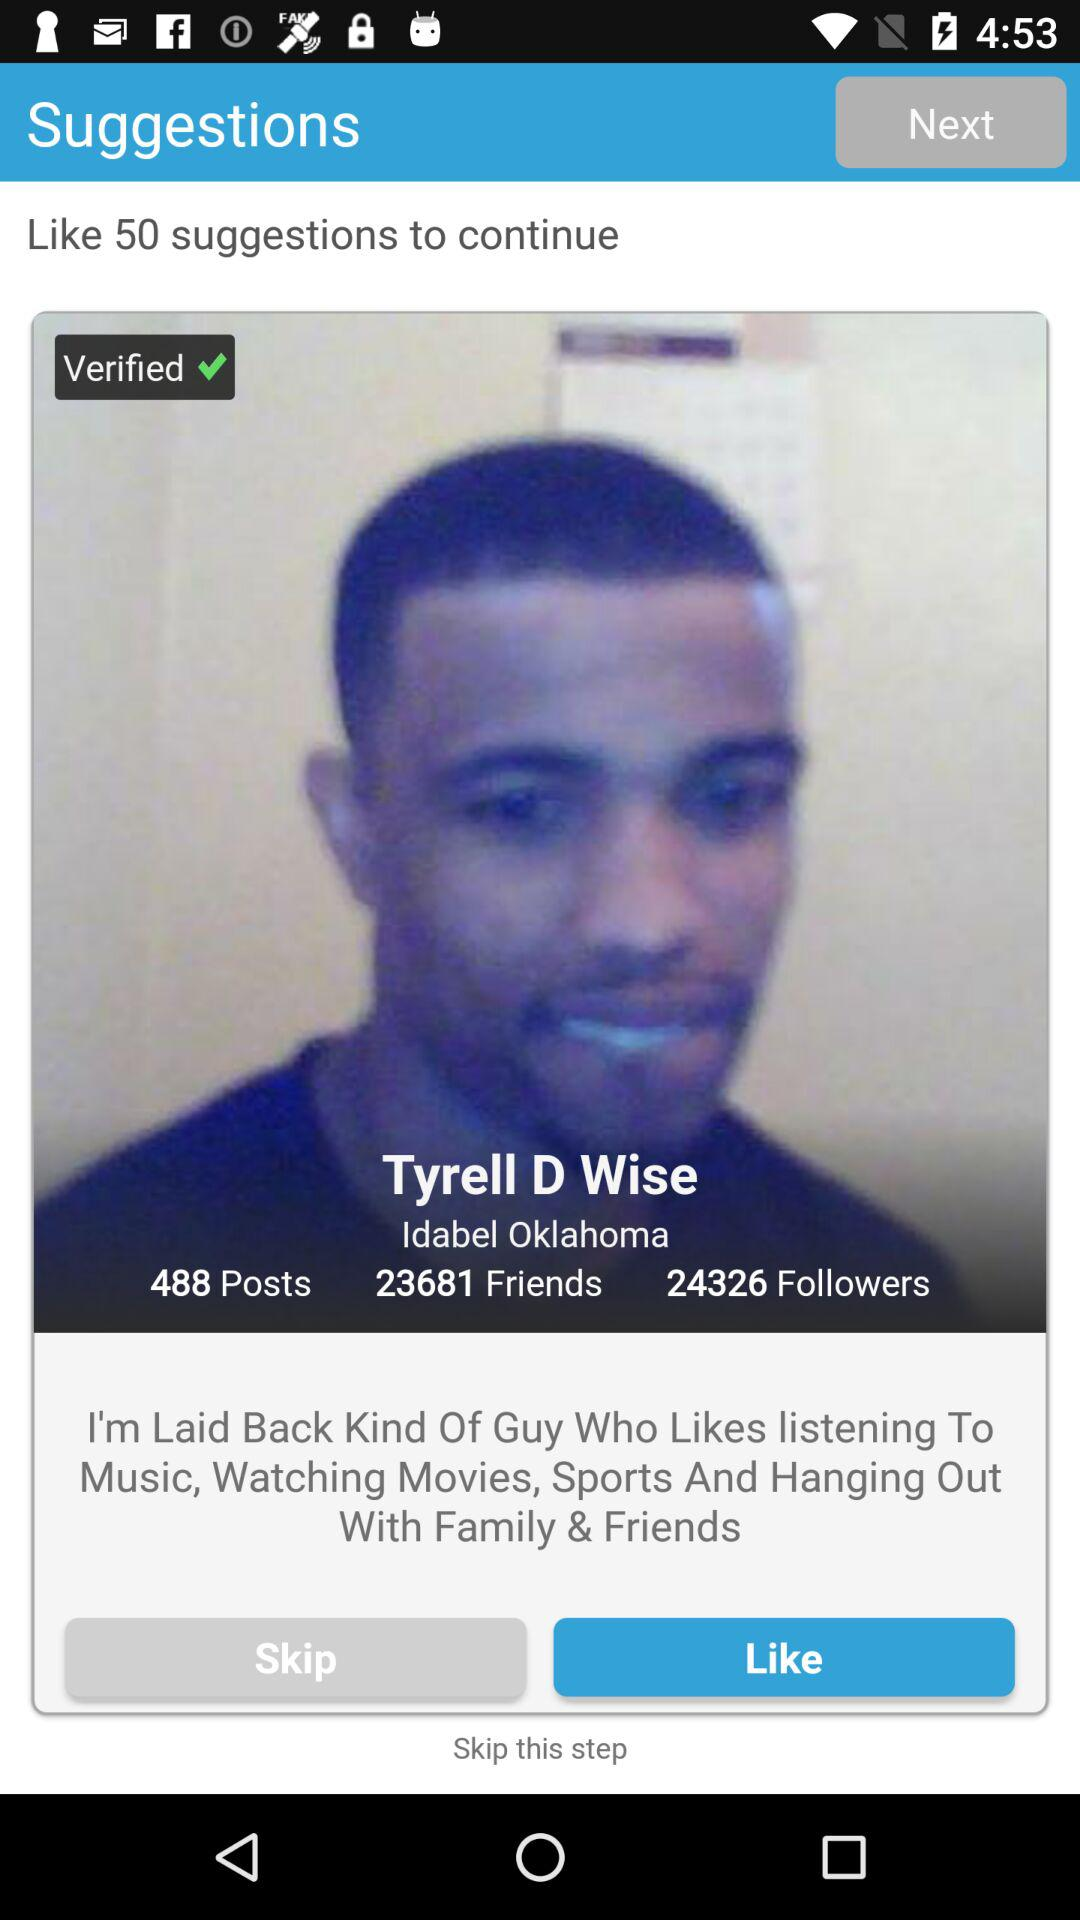What is the location of Tyrell D Wise? The location is Idabel, Oklahoma. 